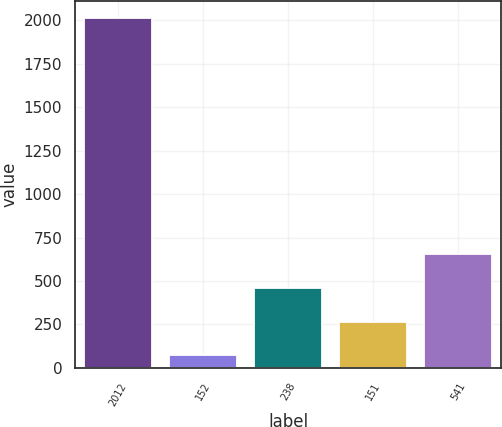Convert chart to OTSL. <chart><loc_0><loc_0><loc_500><loc_500><bar_chart><fcel>2012<fcel>152<fcel>238<fcel>151<fcel>541<nl><fcel>2012<fcel>72<fcel>460<fcel>266<fcel>654<nl></chart> 